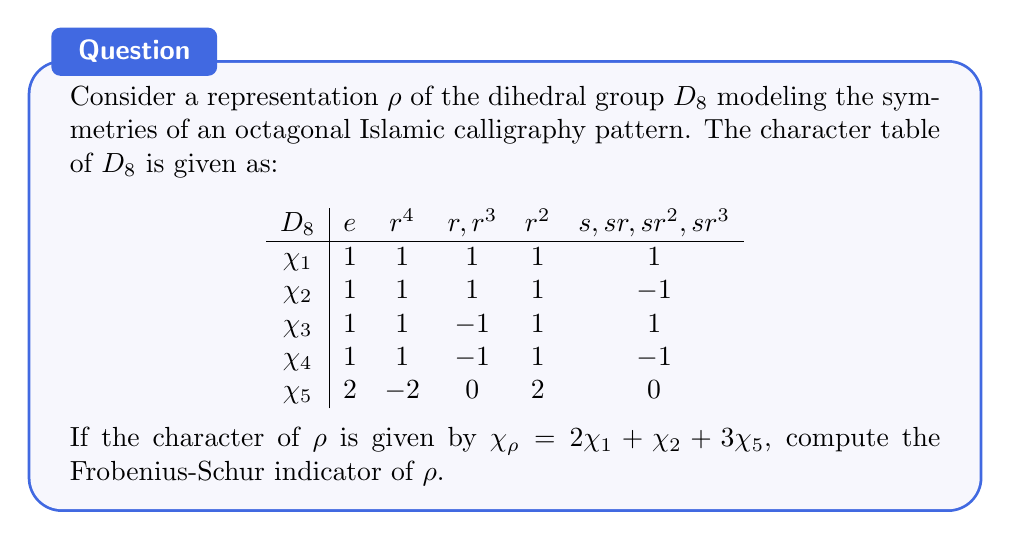Provide a solution to this math problem. Let's approach this step-by-step:

1) The Frobenius-Schur indicator $\nu(\rho)$ for a representation $\rho$ of a finite group $G$ is given by:

   $$\nu(\rho) = \frac{1}{|G|} \sum_{g \in G} \chi_\rho(g^2)$$

2) For $D_8$, we have $|G| = 8$.

3) We need to calculate $\chi_\rho(g^2)$ for each conjugacy class:

   - For $e$: $e^2 = e$, so $\chi_\rho(e^2) = \chi_\rho(e) = 2(1) + 1(1) + 3(2) = 9$
   - For $r^4$: $(r^4)^2 = e$, so $\chi_\rho((r^4)^2) = 9$
   - For $r,r^3$: $(r)^2 = r^2$, so $\chi_\rho((r)^2) = 2(1) + 1(1) + 3(2) = 9$
   - For $r^2$: $(r^2)^2 = r^4$, so $\chi_\rho((r^2)^2) = 2(1) + 1(1) + 3(-2) = -3$
   - For $s,sr,sr^2,sr^3$: $s^2 = e$, so $\chi_\rho(s^2) = 9$

4) Now, let's sum these values, considering the size of each conjugacy class:

   $$\sum_{g \in G} \chi_\rho(g^2) = 1(9) + 1(9) + 2(9) + 1(-3) + 4(9) = 69$$

5) Finally, we can calculate the Frobenius-Schur indicator:

   $$\nu(\rho) = \frac{1}{8} \cdot 69 = \frac{69}{8}$$
Answer: $\frac{69}{8}$ 